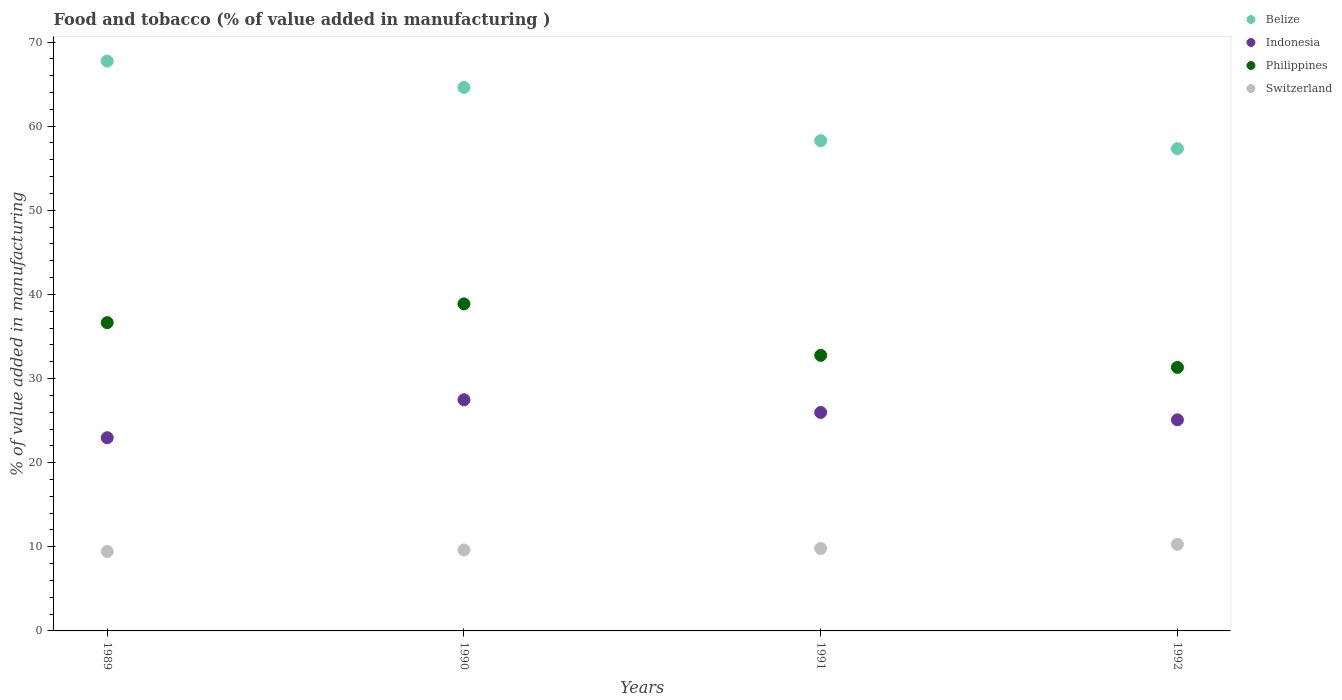How many different coloured dotlines are there?
Your answer should be compact. 4. What is the value added in manufacturing food and tobacco in Philippines in 1991?
Your response must be concise. 32.76. Across all years, what is the maximum value added in manufacturing food and tobacco in Belize?
Give a very brief answer. 67.74. Across all years, what is the minimum value added in manufacturing food and tobacco in Indonesia?
Your response must be concise. 22.97. In which year was the value added in manufacturing food and tobacco in Philippines maximum?
Your answer should be compact. 1990. What is the total value added in manufacturing food and tobacco in Philippines in the graph?
Provide a short and direct response. 139.61. What is the difference between the value added in manufacturing food and tobacco in Switzerland in 1989 and that in 1991?
Your answer should be very brief. -0.35. What is the difference between the value added in manufacturing food and tobacco in Switzerland in 1991 and the value added in manufacturing food and tobacco in Indonesia in 1989?
Keep it short and to the point. -13.17. What is the average value added in manufacturing food and tobacco in Indonesia per year?
Ensure brevity in your answer.  25.38. In the year 1990, what is the difference between the value added in manufacturing food and tobacco in Switzerland and value added in manufacturing food and tobacco in Belize?
Give a very brief answer. -54.98. In how many years, is the value added in manufacturing food and tobacco in Belize greater than 4 %?
Make the answer very short. 4. What is the ratio of the value added in manufacturing food and tobacco in Belize in 1990 to that in 1991?
Keep it short and to the point. 1.11. What is the difference between the highest and the second highest value added in manufacturing food and tobacco in Switzerland?
Ensure brevity in your answer.  0.5. What is the difference between the highest and the lowest value added in manufacturing food and tobacco in Belize?
Offer a terse response. 10.41. Does the value added in manufacturing food and tobacco in Switzerland monotonically increase over the years?
Your response must be concise. Yes. How many dotlines are there?
Offer a very short reply. 4. How many years are there in the graph?
Offer a very short reply. 4. Does the graph contain any zero values?
Your answer should be compact. No. Does the graph contain grids?
Ensure brevity in your answer.  No. Where does the legend appear in the graph?
Ensure brevity in your answer.  Top right. How many legend labels are there?
Give a very brief answer. 4. What is the title of the graph?
Offer a terse response. Food and tobacco (% of value added in manufacturing ). Does "Argentina" appear as one of the legend labels in the graph?
Provide a succinct answer. No. What is the label or title of the Y-axis?
Your answer should be very brief. % of value added in manufacturing. What is the % of value added in manufacturing of Belize in 1989?
Offer a terse response. 67.74. What is the % of value added in manufacturing of Indonesia in 1989?
Your response must be concise. 22.97. What is the % of value added in manufacturing in Philippines in 1989?
Make the answer very short. 36.65. What is the % of value added in manufacturing in Switzerland in 1989?
Your answer should be very brief. 9.45. What is the % of value added in manufacturing in Belize in 1990?
Offer a terse response. 64.61. What is the % of value added in manufacturing in Indonesia in 1990?
Keep it short and to the point. 27.48. What is the % of value added in manufacturing of Philippines in 1990?
Your answer should be very brief. 38.87. What is the % of value added in manufacturing of Switzerland in 1990?
Provide a short and direct response. 9.62. What is the % of value added in manufacturing of Belize in 1991?
Ensure brevity in your answer.  58.28. What is the % of value added in manufacturing in Indonesia in 1991?
Your response must be concise. 25.97. What is the % of value added in manufacturing of Philippines in 1991?
Make the answer very short. 32.76. What is the % of value added in manufacturing of Switzerland in 1991?
Keep it short and to the point. 9.8. What is the % of value added in manufacturing of Belize in 1992?
Your answer should be very brief. 57.33. What is the % of value added in manufacturing of Indonesia in 1992?
Offer a terse response. 25.09. What is the % of value added in manufacturing in Philippines in 1992?
Offer a terse response. 31.33. What is the % of value added in manufacturing in Switzerland in 1992?
Ensure brevity in your answer.  10.3. Across all years, what is the maximum % of value added in manufacturing of Belize?
Provide a short and direct response. 67.74. Across all years, what is the maximum % of value added in manufacturing in Indonesia?
Keep it short and to the point. 27.48. Across all years, what is the maximum % of value added in manufacturing of Philippines?
Offer a very short reply. 38.87. Across all years, what is the maximum % of value added in manufacturing of Switzerland?
Ensure brevity in your answer.  10.3. Across all years, what is the minimum % of value added in manufacturing of Belize?
Make the answer very short. 57.33. Across all years, what is the minimum % of value added in manufacturing in Indonesia?
Your response must be concise. 22.97. Across all years, what is the minimum % of value added in manufacturing of Philippines?
Offer a very short reply. 31.33. Across all years, what is the minimum % of value added in manufacturing in Switzerland?
Your answer should be very brief. 9.45. What is the total % of value added in manufacturing in Belize in the graph?
Your answer should be compact. 247.95. What is the total % of value added in manufacturing of Indonesia in the graph?
Your answer should be compact. 101.51. What is the total % of value added in manufacturing in Philippines in the graph?
Offer a terse response. 139.61. What is the total % of value added in manufacturing of Switzerland in the graph?
Your answer should be compact. 39.16. What is the difference between the % of value added in manufacturing in Belize in 1989 and that in 1990?
Offer a very short reply. 3.13. What is the difference between the % of value added in manufacturing of Indonesia in 1989 and that in 1990?
Keep it short and to the point. -4.51. What is the difference between the % of value added in manufacturing of Philippines in 1989 and that in 1990?
Your answer should be compact. -2.23. What is the difference between the % of value added in manufacturing in Switzerland in 1989 and that in 1990?
Provide a short and direct response. -0.17. What is the difference between the % of value added in manufacturing of Belize in 1989 and that in 1991?
Provide a succinct answer. 9.46. What is the difference between the % of value added in manufacturing in Indonesia in 1989 and that in 1991?
Ensure brevity in your answer.  -3.01. What is the difference between the % of value added in manufacturing of Philippines in 1989 and that in 1991?
Your response must be concise. 3.89. What is the difference between the % of value added in manufacturing of Switzerland in 1989 and that in 1991?
Offer a terse response. -0.35. What is the difference between the % of value added in manufacturing of Belize in 1989 and that in 1992?
Your answer should be compact. 10.41. What is the difference between the % of value added in manufacturing of Indonesia in 1989 and that in 1992?
Your answer should be compact. -2.13. What is the difference between the % of value added in manufacturing in Philippines in 1989 and that in 1992?
Offer a very short reply. 5.32. What is the difference between the % of value added in manufacturing of Switzerland in 1989 and that in 1992?
Your response must be concise. -0.85. What is the difference between the % of value added in manufacturing of Belize in 1990 and that in 1991?
Your answer should be very brief. 6.33. What is the difference between the % of value added in manufacturing of Indonesia in 1990 and that in 1991?
Ensure brevity in your answer.  1.51. What is the difference between the % of value added in manufacturing in Philippines in 1990 and that in 1991?
Provide a short and direct response. 6.12. What is the difference between the % of value added in manufacturing in Switzerland in 1990 and that in 1991?
Your answer should be very brief. -0.18. What is the difference between the % of value added in manufacturing of Belize in 1990 and that in 1992?
Give a very brief answer. 7.28. What is the difference between the % of value added in manufacturing of Indonesia in 1990 and that in 1992?
Provide a succinct answer. 2.38. What is the difference between the % of value added in manufacturing in Philippines in 1990 and that in 1992?
Offer a very short reply. 7.55. What is the difference between the % of value added in manufacturing in Switzerland in 1990 and that in 1992?
Provide a succinct answer. -0.68. What is the difference between the % of value added in manufacturing in Belize in 1991 and that in 1992?
Offer a terse response. 0.95. What is the difference between the % of value added in manufacturing of Indonesia in 1991 and that in 1992?
Make the answer very short. 0.88. What is the difference between the % of value added in manufacturing in Philippines in 1991 and that in 1992?
Ensure brevity in your answer.  1.43. What is the difference between the % of value added in manufacturing of Switzerland in 1991 and that in 1992?
Offer a very short reply. -0.5. What is the difference between the % of value added in manufacturing in Belize in 1989 and the % of value added in manufacturing in Indonesia in 1990?
Offer a very short reply. 40.26. What is the difference between the % of value added in manufacturing of Belize in 1989 and the % of value added in manufacturing of Philippines in 1990?
Ensure brevity in your answer.  28.86. What is the difference between the % of value added in manufacturing of Belize in 1989 and the % of value added in manufacturing of Switzerland in 1990?
Your answer should be very brief. 58.12. What is the difference between the % of value added in manufacturing in Indonesia in 1989 and the % of value added in manufacturing in Philippines in 1990?
Give a very brief answer. -15.91. What is the difference between the % of value added in manufacturing in Indonesia in 1989 and the % of value added in manufacturing in Switzerland in 1990?
Keep it short and to the point. 13.35. What is the difference between the % of value added in manufacturing in Philippines in 1989 and the % of value added in manufacturing in Switzerland in 1990?
Your answer should be very brief. 27.03. What is the difference between the % of value added in manufacturing of Belize in 1989 and the % of value added in manufacturing of Indonesia in 1991?
Offer a terse response. 41.76. What is the difference between the % of value added in manufacturing in Belize in 1989 and the % of value added in manufacturing in Philippines in 1991?
Offer a very short reply. 34.98. What is the difference between the % of value added in manufacturing in Belize in 1989 and the % of value added in manufacturing in Switzerland in 1991?
Provide a short and direct response. 57.94. What is the difference between the % of value added in manufacturing in Indonesia in 1989 and the % of value added in manufacturing in Philippines in 1991?
Offer a very short reply. -9.79. What is the difference between the % of value added in manufacturing in Indonesia in 1989 and the % of value added in manufacturing in Switzerland in 1991?
Offer a terse response. 13.17. What is the difference between the % of value added in manufacturing in Philippines in 1989 and the % of value added in manufacturing in Switzerland in 1991?
Ensure brevity in your answer.  26.85. What is the difference between the % of value added in manufacturing in Belize in 1989 and the % of value added in manufacturing in Indonesia in 1992?
Provide a short and direct response. 42.64. What is the difference between the % of value added in manufacturing in Belize in 1989 and the % of value added in manufacturing in Philippines in 1992?
Ensure brevity in your answer.  36.41. What is the difference between the % of value added in manufacturing of Belize in 1989 and the % of value added in manufacturing of Switzerland in 1992?
Offer a terse response. 57.44. What is the difference between the % of value added in manufacturing of Indonesia in 1989 and the % of value added in manufacturing of Philippines in 1992?
Give a very brief answer. -8.36. What is the difference between the % of value added in manufacturing of Indonesia in 1989 and the % of value added in manufacturing of Switzerland in 1992?
Provide a succinct answer. 12.67. What is the difference between the % of value added in manufacturing in Philippines in 1989 and the % of value added in manufacturing in Switzerland in 1992?
Your response must be concise. 26.35. What is the difference between the % of value added in manufacturing in Belize in 1990 and the % of value added in manufacturing in Indonesia in 1991?
Provide a succinct answer. 38.63. What is the difference between the % of value added in manufacturing in Belize in 1990 and the % of value added in manufacturing in Philippines in 1991?
Offer a very short reply. 31.85. What is the difference between the % of value added in manufacturing of Belize in 1990 and the % of value added in manufacturing of Switzerland in 1991?
Ensure brevity in your answer.  54.81. What is the difference between the % of value added in manufacturing in Indonesia in 1990 and the % of value added in manufacturing in Philippines in 1991?
Give a very brief answer. -5.28. What is the difference between the % of value added in manufacturing in Indonesia in 1990 and the % of value added in manufacturing in Switzerland in 1991?
Make the answer very short. 17.68. What is the difference between the % of value added in manufacturing of Philippines in 1990 and the % of value added in manufacturing of Switzerland in 1991?
Offer a very short reply. 29.08. What is the difference between the % of value added in manufacturing of Belize in 1990 and the % of value added in manufacturing of Indonesia in 1992?
Provide a succinct answer. 39.51. What is the difference between the % of value added in manufacturing of Belize in 1990 and the % of value added in manufacturing of Philippines in 1992?
Make the answer very short. 33.28. What is the difference between the % of value added in manufacturing in Belize in 1990 and the % of value added in manufacturing in Switzerland in 1992?
Your answer should be compact. 54.31. What is the difference between the % of value added in manufacturing in Indonesia in 1990 and the % of value added in manufacturing in Philippines in 1992?
Ensure brevity in your answer.  -3.85. What is the difference between the % of value added in manufacturing of Indonesia in 1990 and the % of value added in manufacturing of Switzerland in 1992?
Provide a succinct answer. 17.18. What is the difference between the % of value added in manufacturing of Philippines in 1990 and the % of value added in manufacturing of Switzerland in 1992?
Offer a terse response. 28.58. What is the difference between the % of value added in manufacturing of Belize in 1991 and the % of value added in manufacturing of Indonesia in 1992?
Offer a terse response. 33.18. What is the difference between the % of value added in manufacturing in Belize in 1991 and the % of value added in manufacturing in Philippines in 1992?
Make the answer very short. 26.95. What is the difference between the % of value added in manufacturing of Belize in 1991 and the % of value added in manufacturing of Switzerland in 1992?
Your answer should be compact. 47.98. What is the difference between the % of value added in manufacturing in Indonesia in 1991 and the % of value added in manufacturing in Philippines in 1992?
Provide a succinct answer. -5.35. What is the difference between the % of value added in manufacturing in Indonesia in 1991 and the % of value added in manufacturing in Switzerland in 1992?
Offer a terse response. 15.68. What is the difference between the % of value added in manufacturing of Philippines in 1991 and the % of value added in manufacturing of Switzerland in 1992?
Keep it short and to the point. 22.46. What is the average % of value added in manufacturing of Belize per year?
Provide a succinct answer. 61.99. What is the average % of value added in manufacturing in Indonesia per year?
Offer a very short reply. 25.38. What is the average % of value added in manufacturing of Philippines per year?
Make the answer very short. 34.9. What is the average % of value added in manufacturing in Switzerland per year?
Your answer should be very brief. 9.79. In the year 1989, what is the difference between the % of value added in manufacturing of Belize and % of value added in manufacturing of Indonesia?
Keep it short and to the point. 44.77. In the year 1989, what is the difference between the % of value added in manufacturing of Belize and % of value added in manufacturing of Philippines?
Offer a terse response. 31.09. In the year 1989, what is the difference between the % of value added in manufacturing of Belize and % of value added in manufacturing of Switzerland?
Ensure brevity in your answer.  58.29. In the year 1989, what is the difference between the % of value added in manufacturing of Indonesia and % of value added in manufacturing of Philippines?
Your answer should be compact. -13.68. In the year 1989, what is the difference between the % of value added in manufacturing in Indonesia and % of value added in manufacturing in Switzerland?
Provide a short and direct response. 13.52. In the year 1989, what is the difference between the % of value added in manufacturing in Philippines and % of value added in manufacturing in Switzerland?
Offer a very short reply. 27.2. In the year 1990, what is the difference between the % of value added in manufacturing of Belize and % of value added in manufacturing of Indonesia?
Your answer should be very brief. 37.13. In the year 1990, what is the difference between the % of value added in manufacturing in Belize and % of value added in manufacturing in Philippines?
Provide a succinct answer. 25.73. In the year 1990, what is the difference between the % of value added in manufacturing of Belize and % of value added in manufacturing of Switzerland?
Ensure brevity in your answer.  54.98. In the year 1990, what is the difference between the % of value added in manufacturing in Indonesia and % of value added in manufacturing in Philippines?
Offer a terse response. -11.4. In the year 1990, what is the difference between the % of value added in manufacturing of Indonesia and % of value added in manufacturing of Switzerland?
Your answer should be very brief. 17.86. In the year 1990, what is the difference between the % of value added in manufacturing of Philippines and % of value added in manufacturing of Switzerland?
Ensure brevity in your answer.  29.25. In the year 1991, what is the difference between the % of value added in manufacturing of Belize and % of value added in manufacturing of Indonesia?
Keep it short and to the point. 32.3. In the year 1991, what is the difference between the % of value added in manufacturing of Belize and % of value added in manufacturing of Philippines?
Provide a succinct answer. 25.52. In the year 1991, what is the difference between the % of value added in manufacturing of Belize and % of value added in manufacturing of Switzerland?
Your answer should be very brief. 48.48. In the year 1991, what is the difference between the % of value added in manufacturing of Indonesia and % of value added in manufacturing of Philippines?
Your answer should be very brief. -6.79. In the year 1991, what is the difference between the % of value added in manufacturing of Indonesia and % of value added in manufacturing of Switzerland?
Offer a terse response. 16.17. In the year 1991, what is the difference between the % of value added in manufacturing in Philippines and % of value added in manufacturing in Switzerland?
Offer a terse response. 22.96. In the year 1992, what is the difference between the % of value added in manufacturing of Belize and % of value added in manufacturing of Indonesia?
Your answer should be compact. 32.23. In the year 1992, what is the difference between the % of value added in manufacturing in Belize and % of value added in manufacturing in Philippines?
Keep it short and to the point. 26. In the year 1992, what is the difference between the % of value added in manufacturing of Belize and % of value added in manufacturing of Switzerland?
Provide a succinct answer. 47.03. In the year 1992, what is the difference between the % of value added in manufacturing in Indonesia and % of value added in manufacturing in Philippines?
Your answer should be compact. -6.23. In the year 1992, what is the difference between the % of value added in manufacturing of Indonesia and % of value added in manufacturing of Switzerland?
Your answer should be compact. 14.8. In the year 1992, what is the difference between the % of value added in manufacturing in Philippines and % of value added in manufacturing in Switzerland?
Your answer should be compact. 21.03. What is the ratio of the % of value added in manufacturing in Belize in 1989 to that in 1990?
Your answer should be compact. 1.05. What is the ratio of the % of value added in manufacturing in Indonesia in 1989 to that in 1990?
Your answer should be very brief. 0.84. What is the ratio of the % of value added in manufacturing of Philippines in 1989 to that in 1990?
Keep it short and to the point. 0.94. What is the ratio of the % of value added in manufacturing in Switzerland in 1989 to that in 1990?
Your answer should be very brief. 0.98. What is the ratio of the % of value added in manufacturing of Belize in 1989 to that in 1991?
Provide a short and direct response. 1.16. What is the ratio of the % of value added in manufacturing in Indonesia in 1989 to that in 1991?
Ensure brevity in your answer.  0.88. What is the ratio of the % of value added in manufacturing in Philippines in 1989 to that in 1991?
Keep it short and to the point. 1.12. What is the ratio of the % of value added in manufacturing of Belize in 1989 to that in 1992?
Keep it short and to the point. 1.18. What is the ratio of the % of value added in manufacturing in Indonesia in 1989 to that in 1992?
Offer a very short reply. 0.92. What is the ratio of the % of value added in manufacturing in Philippines in 1989 to that in 1992?
Give a very brief answer. 1.17. What is the ratio of the % of value added in manufacturing of Switzerland in 1989 to that in 1992?
Make the answer very short. 0.92. What is the ratio of the % of value added in manufacturing in Belize in 1990 to that in 1991?
Ensure brevity in your answer.  1.11. What is the ratio of the % of value added in manufacturing of Indonesia in 1990 to that in 1991?
Your answer should be compact. 1.06. What is the ratio of the % of value added in manufacturing in Philippines in 1990 to that in 1991?
Offer a terse response. 1.19. What is the ratio of the % of value added in manufacturing in Switzerland in 1990 to that in 1991?
Your answer should be compact. 0.98. What is the ratio of the % of value added in manufacturing in Belize in 1990 to that in 1992?
Keep it short and to the point. 1.13. What is the ratio of the % of value added in manufacturing in Indonesia in 1990 to that in 1992?
Provide a short and direct response. 1.09. What is the ratio of the % of value added in manufacturing of Philippines in 1990 to that in 1992?
Provide a succinct answer. 1.24. What is the ratio of the % of value added in manufacturing of Switzerland in 1990 to that in 1992?
Ensure brevity in your answer.  0.93. What is the ratio of the % of value added in manufacturing in Belize in 1991 to that in 1992?
Provide a short and direct response. 1.02. What is the ratio of the % of value added in manufacturing in Indonesia in 1991 to that in 1992?
Offer a terse response. 1.03. What is the ratio of the % of value added in manufacturing in Philippines in 1991 to that in 1992?
Provide a short and direct response. 1.05. What is the ratio of the % of value added in manufacturing of Switzerland in 1991 to that in 1992?
Give a very brief answer. 0.95. What is the difference between the highest and the second highest % of value added in manufacturing of Belize?
Your answer should be very brief. 3.13. What is the difference between the highest and the second highest % of value added in manufacturing of Indonesia?
Make the answer very short. 1.51. What is the difference between the highest and the second highest % of value added in manufacturing in Philippines?
Your response must be concise. 2.23. What is the difference between the highest and the second highest % of value added in manufacturing in Switzerland?
Offer a terse response. 0.5. What is the difference between the highest and the lowest % of value added in manufacturing in Belize?
Make the answer very short. 10.41. What is the difference between the highest and the lowest % of value added in manufacturing in Indonesia?
Your answer should be compact. 4.51. What is the difference between the highest and the lowest % of value added in manufacturing in Philippines?
Give a very brief answer. 7.55. What is the difference between the highest and the lowest % of value added in manufacturing in Switzerland?
Keep it short and to the point. 0.85. 